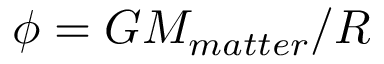<formula> <loc_0><loc_0><loc_500><loc_500>\phi = G M _ { m a t t e r } / R</formula> 